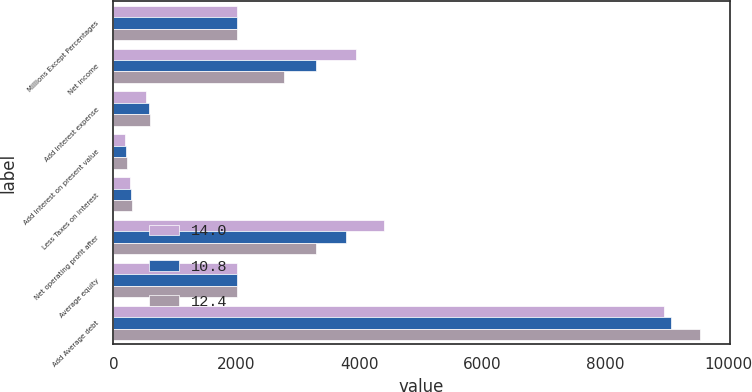<chart> <loc_0><loc_0><loc_500><loc_500><stacked_bar_chart><ecel><fcel>Millions Except Percentages<fcel>Net income<fcel>Add Interest expense<fcel>Add Interest on present value<fcel>Less Taxes on interest<fcel>Net operating profit after<fcel>Average equity<fcel>Add Average debt<nl><fcel>14<fcel>2012<fcel>3943<fcel>535<fcel>190<fcel>273<fcel>4395<fcel>2011<fcel>8952<nl><fcel>10.8<fcel>2011<fcel>3292<fcel>572<fcel>208<fcel>293<fcel>3779<fcel>2011<fcel>9074<nl><fcel>12.4<fcel>2010<fcel>2780<fcel>602<fcel>222<fcel>307<fcel>3297<fcel>2011<fcel>9545<nl></chart> 